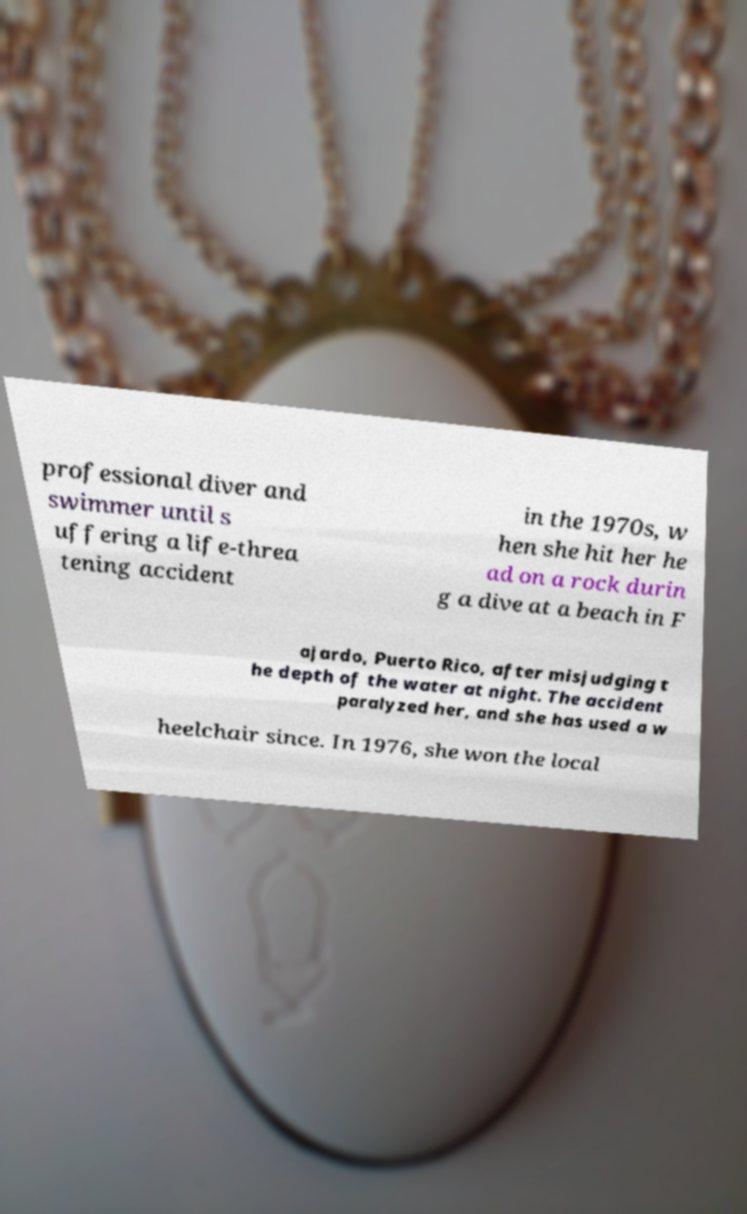Please identify and transcribe the text found in this image. professional diver and swimmer until s uffering a life-threa tening accident in the 1970s, w hen she hit her he ad on a rock durin g a dive at a beach in F ajardo, Puerto Rico, after misjudging t he depth of the water at night. The accident paralyzed her, and she has used a w heelchair since. In 1976, she won the local 